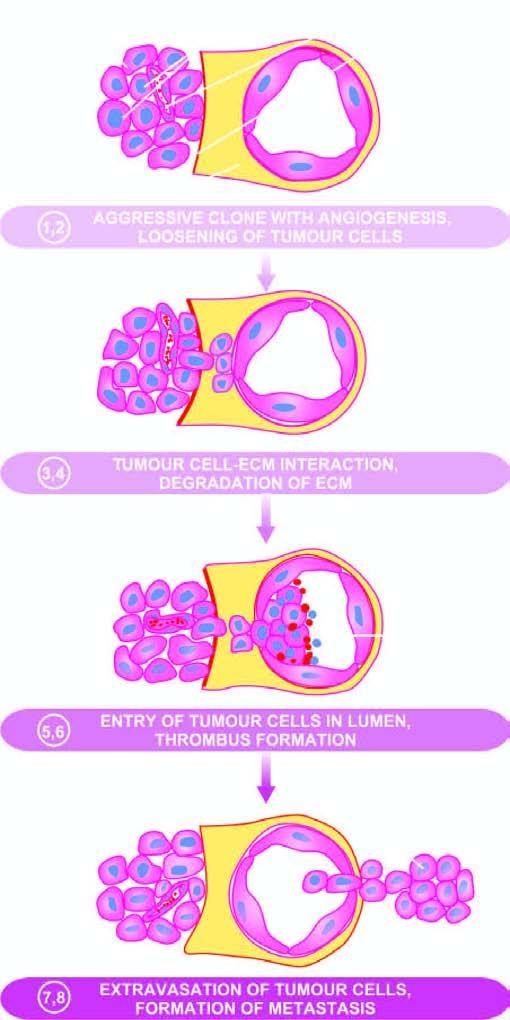the serial numbers in the figure correspond to whose description in the text?
Answer the question using a single word or phrase. Their 